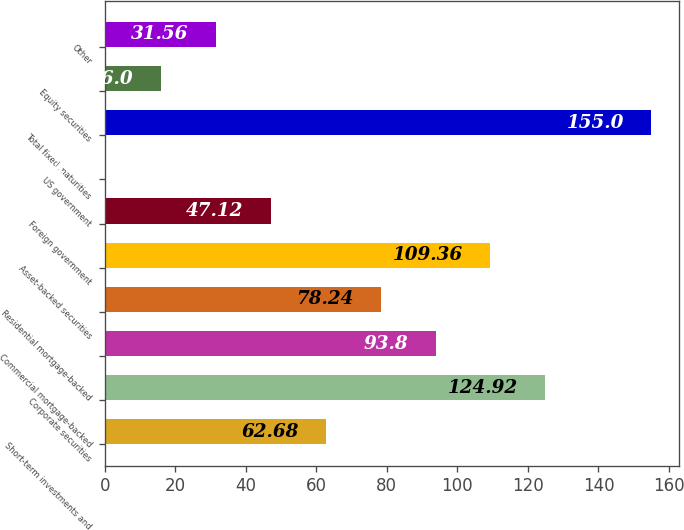Convert chart. <chart><loc_0><loc_0><loc_500><loc_500><bar_chart><fcel>Short-term investments and<fcel>Corporate securities<fcel>Commercial mortgage-backed<fcel>Residential mortgage-backed<fcel>Asset-backed securities<fcel>Foreign government<fcel>US government<fcel>Total fixed maturities<fcel>Equity securities<fcel>Other<nl><fcel>62.68<fcel>124.92<fcel>93.8<fcel>78.24<fcel>109.36<fcel>47.12<fcel>0.44<fcel>155<fcel>16<fcel>31.56<nl></chart> 